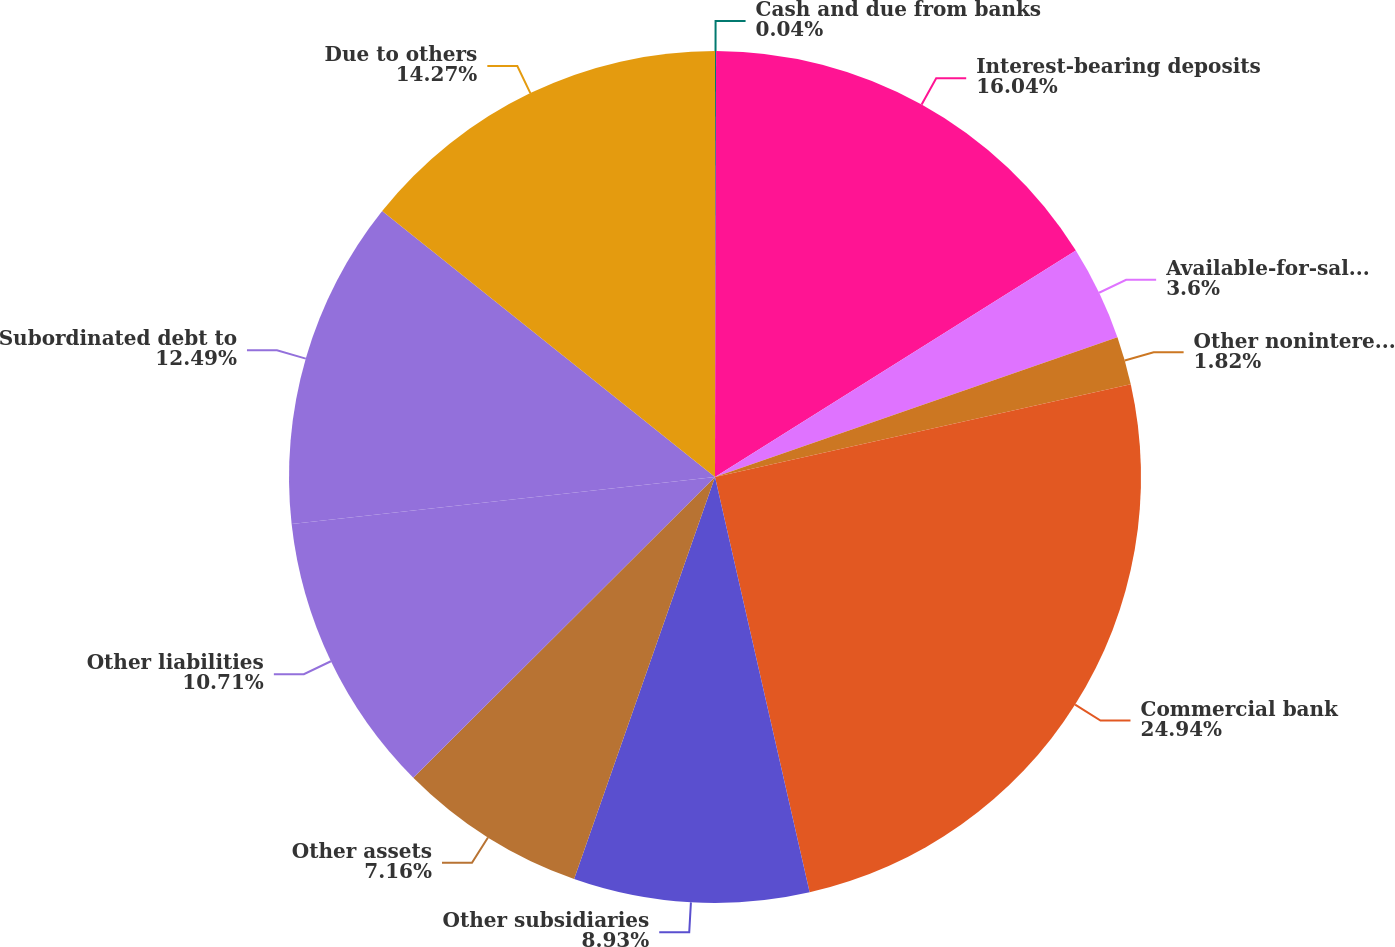<chart> <loc_0><loc_0><loc_500><loc_500><pie_chart><fcel>Cash and due from banks<fcel>Interest-bearing deposits<fcel>Available-for-sale at fair<fcel>Other noninterest-bearing<fcel>Commercial bank<fcel>Other subsidiaries<fcel>Other assets<fcel>Other liabilities<fcel>Subordinated debt to<fcel>Due to others<nl><fcel>0.04%<fcel>16.04%<fcel>3.6%<fcel>1.82%<fcel>24.93%<fcel>8.93%<fcel>7.16%<fcel>10.71%<fcel>12.49%<fcel>14.27%<nl></chart> 